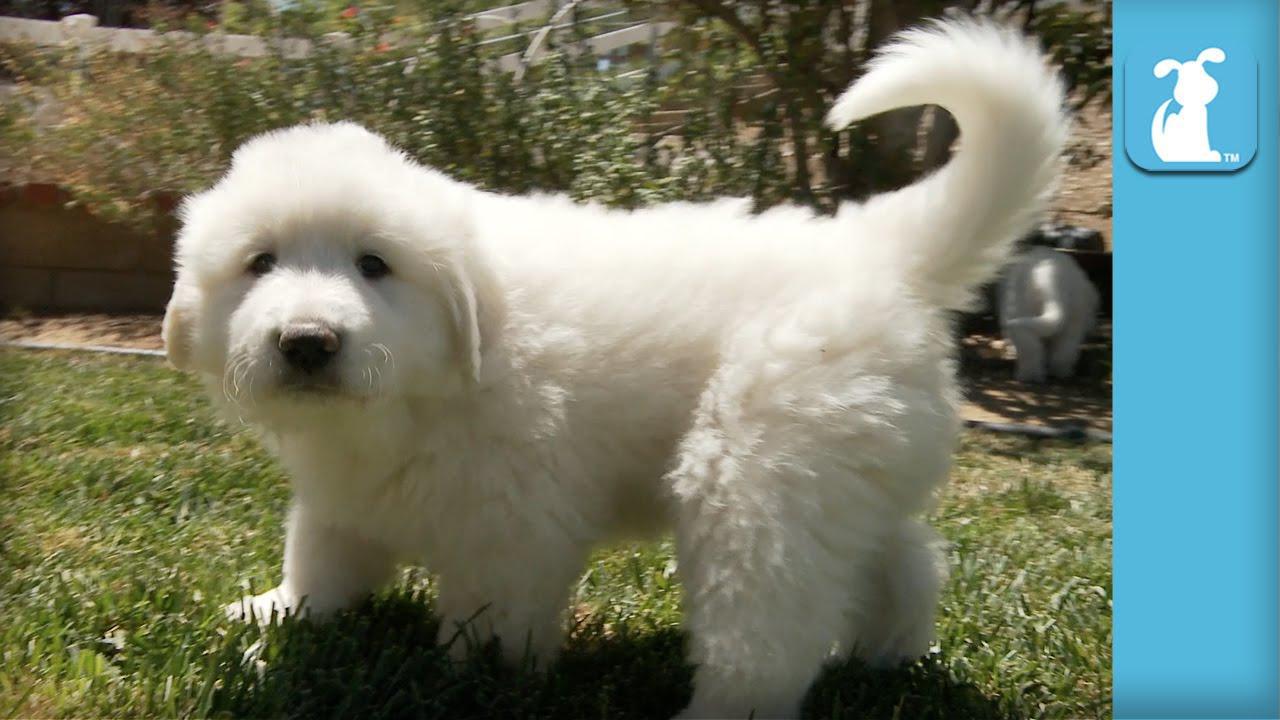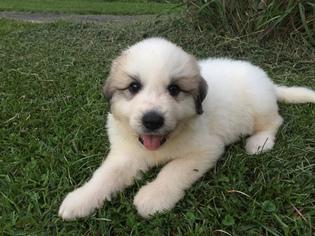The first image is the image on the left, the second image is the image on the right. Evaluate the accuracy of this statement regarding the images: "An image shows a fluffy dog reclining on the grass.". Is it true? Answer yes or no. Yes. 